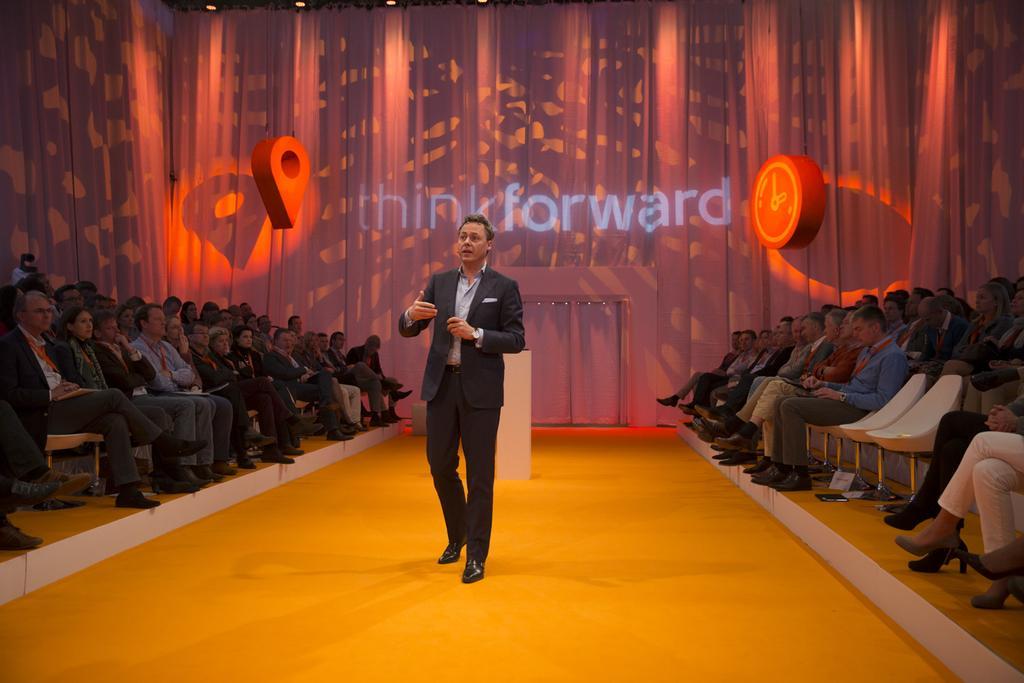In one or two sentences, can you explain what this image depicts? In the picture we can see a man standing on the floor and talking something, he is with a black blazer, and shirt and both the sides of him we can see people are sitting on the chairs and watching him and in the background we can see a wall with some designs and name on it as think forward. 